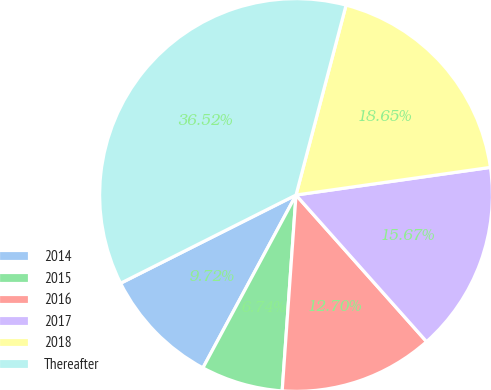Convert chart to OTSL. <chart><loc_0><loc_0><loc_500><loc_500><pie_chart><fcel>2014<fcel>2015<fcel>2016<fcel>2017<fcel>2018<fcel>Thereafter<nl><fcel>9.72%<fcel>6.74%<fcel>12.7%<fcel>15.67%<fcel>18.65%<fcel>36.52%<nl></chart> 